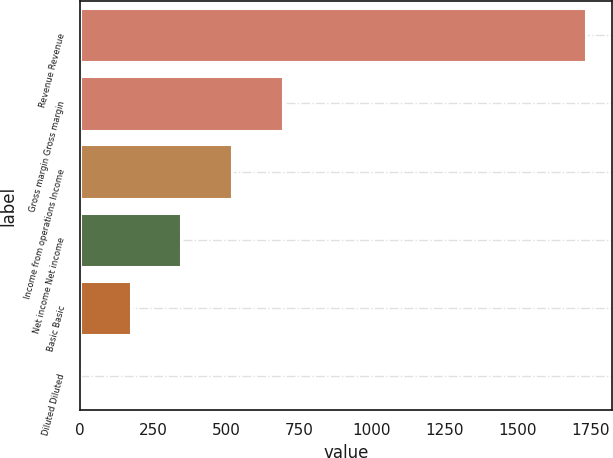Convert chart to OTSL. <chart><loc_0><loc_0><loc_500><loc_500><bar_chart><fcel>Revenue Revenue<fcel>Gross margin Gross margin<fcel>Income from operations Income<fcel>Net income Net income<fcel>Basic Basic<fcel>Diluted Diluted<nl><fcel>1734<fcel>693.87<fcel>520.51<fcel>347.15<fcel>173.79<fcel>0.43<nl></chart> 